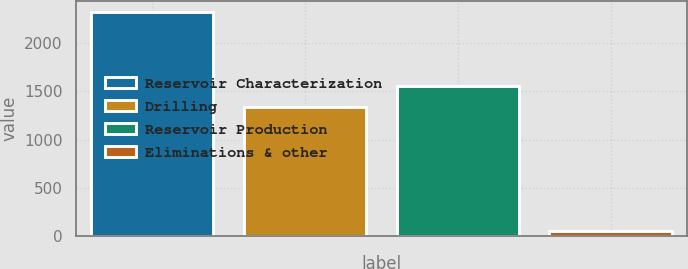Convert chart to OTSL. <chart><loc_0><loc_0><loc_500><loc_500><bar_chart><fcel>Reservoir Characterization<fcel>Drilling<fcel>Reservoir Production<fcel>Eliminations & other<nl><fcel>2321<fcel>1334<fcel>1561.3<fcel>48<nl></chart> 